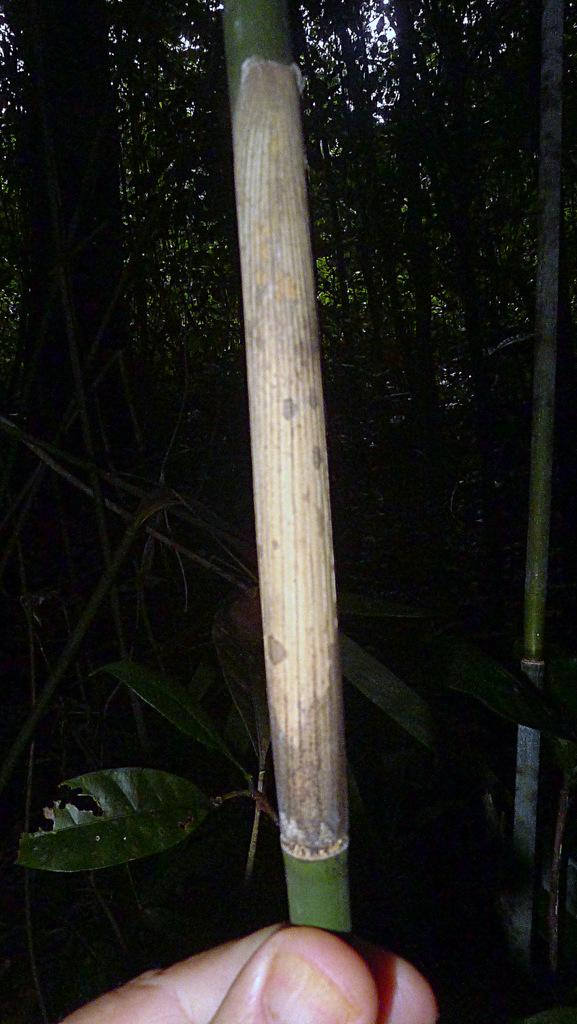How many people are in the image? There are persons in the image, but the exact number is not specified. What are the persons holding in their hands? The persons are holding wooden sticks in their hands. What type of vegetation can be seen in the image? There are plants and trees visible in the image. Is there a rainstorm happening in the image? There is no mention of a rainstorm in the image, so we cannot confirm its presence. What type of stage is visible in the image? There is no stage present in the image. 